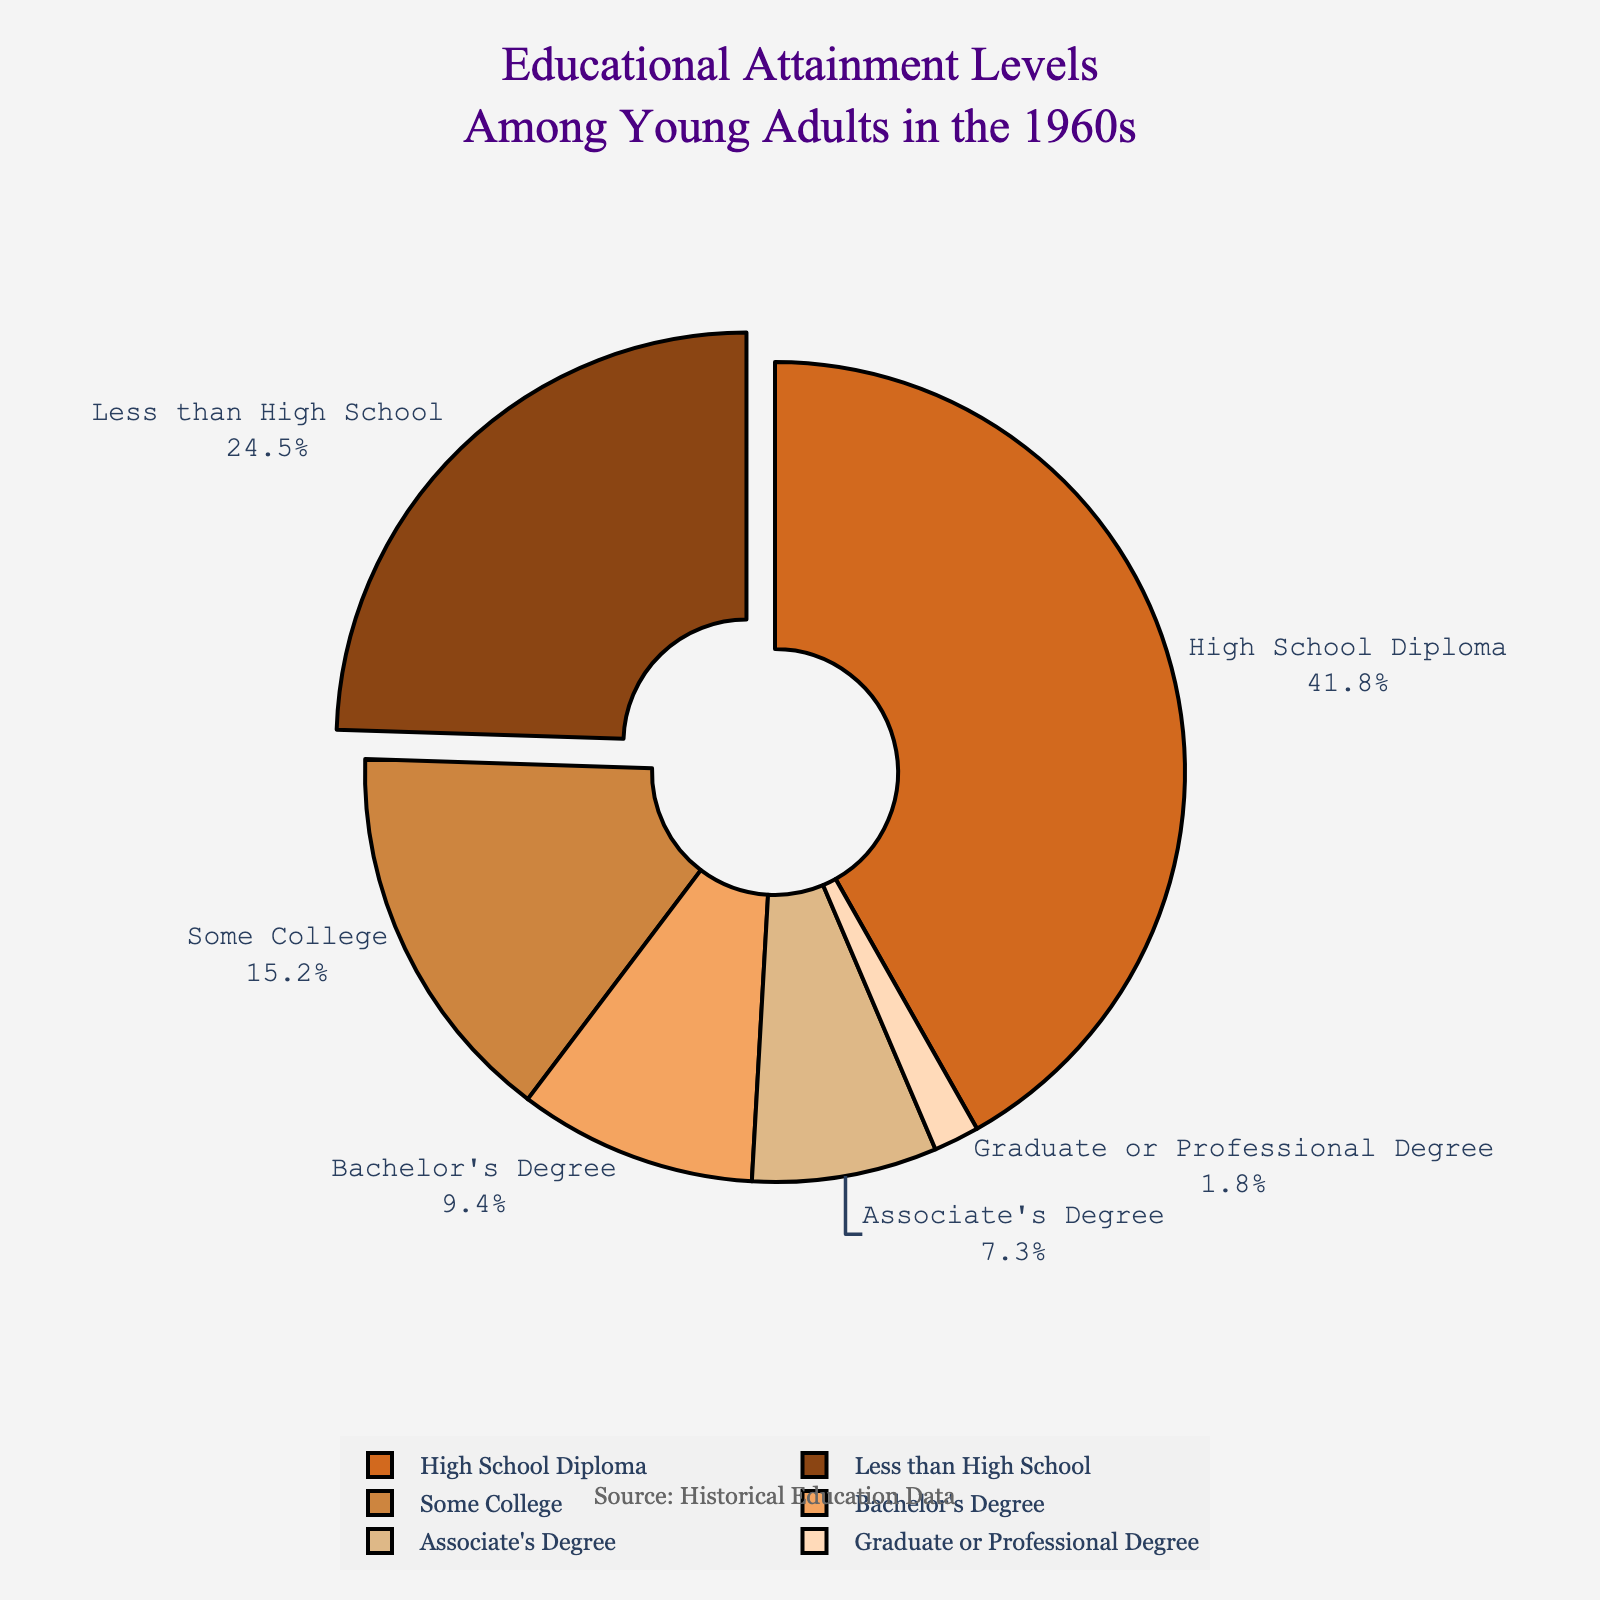What percentage of young adults in the 1960s attained a Bachelor's Degree or higher? To find the percentage of young adults with a Bachelor's Degree or higher, sum the percentages for both Bachelor's Degree and Graduate or Professional Degree. These values are 9.4% and 1.8%, respectively. Adding these together gives 9.4 + 1.8 = 11.2%.
Answer: 11.2% Which education level has the highest percentage among young adults in the 1960s? The chart shows the percentages for each education level. The education level with the highest percentage is High School Diploma at 41.8%.
Answer: High School Diploma How does the percentage of young adults with less than a high school education compare to those with an Associate's Degree? Compare the two percentages: Less than High School is 24.5% and Associate's Degree is 7.3%. 24.5% is greater than 7.3%.
Answer: Less than High School > Associate's Degree What is the total percentage of young adults who did not pursue any form of higher education beyond high school? Add the percentages for Less than High School and High School Diploma. These values are 24.5% and 41.8%, respectively. Thus, 24.5 + 41.8 = 66.3%.
Answer: 66.3% What percentage of young adults in the 1960s attained at least some college education but did not complete a Bachelor's Degree? Sum the percentages for Some College and Associate's Degree. The values are 15.2% and 7.3%, respectively. Adding these together gives 15.2 + 7.3 = 22.5%.
Answer: 22.5% Which segment is visually identified as being slightly pulled out from the chart? Observe the segment of the pie chart that is slightly separated; it corresponds to the High School Diploma category.
Answer: High School Diploma What is the color of the segment representing Graduate or Professional Degree? Looking at the colors corresponding to each segment, the Graduate or Professional Degree segment is represented by a peach color.
Answer: peach If the Graduate or Professional Degree segment were doubled in percentage, what would its new value be? The current percentage is 1.8%. Doubling this value gives 1.8 × 2 = 3.6%.
Answer: 3.6% Compare the combined percentage of young adults with an Associate's Degree or less to those with at least a Bachelor's Degree or higher. The combined percentage for Associate's Degree or less is 24.5% + 41.8% + 15.2% + 7.3% = 88.8%. The percentage for Bachelor's Degree or higher is 9.4% + 1.8% = 11.2%. Since 88.8% is significantly larger than 11.2%, younger adults were less likely to attain higher education past an Associate’s Degree in the 1960s.
Answer: 88.8% > 11.2% 